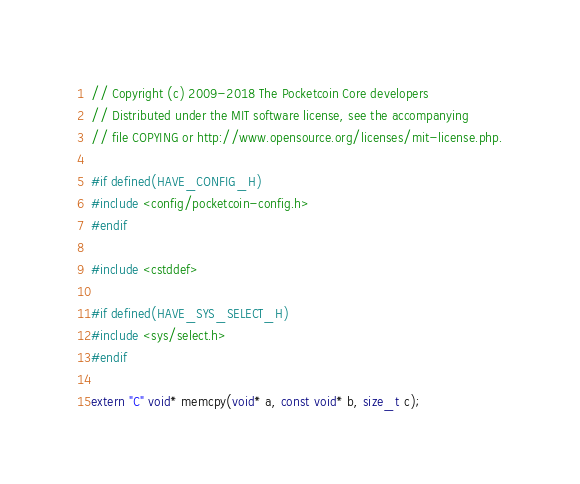Convert code to text. <code><loc_0><loc_0><loc_500><loc_500><_C++_>// Copyright (c) 2009-2018 The Pocketcoin Core developers
// Distributed under the MIT software license, see the accompanying
// file COPYING or http://www.opensource.org/licenses/mit-license.php.

#if defined(HAVE_CONFIG_H)
#include <config/pocketcoin-config.h>
#endif

#include <cstddef>

#if defined(HAVE_SYS_SELECT_H)
#include <sys/select.h>
#endif

extern "C" void* memcpy(void* a, const void* b, size_t c);</code> 